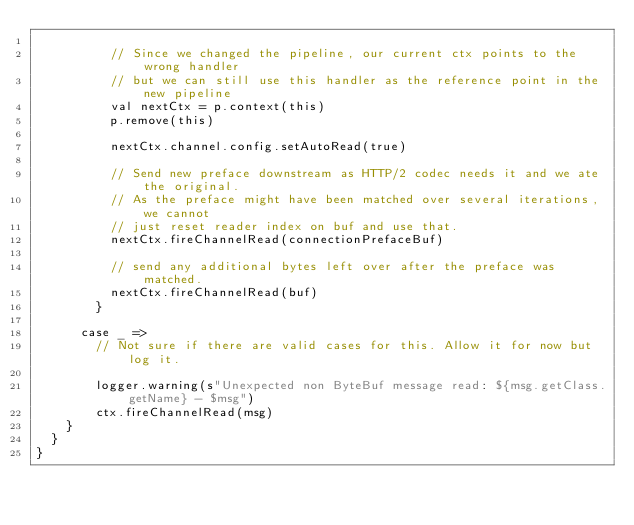Convert code to text. <code><loc_0><loc_0><loc_500><loc_500><_Scala_>
          // Since we changed the pipeline, our current ctx points to the wrong handler
          // but we can still use this handler as the reference point in the new pipeline
          val nextCtx = p.context(this)
          p.remove(this)

          nextCtx.channel.config.setAutoRead(true)

          // Send new preface downstream as HTTP/2 codec needs it and we ate the original.
          // As the preface might have been matched over several iterations, we cannot
          // just reset reader index on buf and use that.
          nextCtx.fireChannelRead(connectionPrefaceBuf)

          // send any additional bytes left over after the preface was matched.
          nextCtx.fireChannelRead(buf)
        }

      case _ =>
        // Not sure if there are valid cases for this. Allow it for now but log it.

        logger.warning(s"Unexpected non ByteBuf message read: ${msg.getClass.getName} - $msg")
        ctx.fireChannelRead(msg)
    }
  }
}
</code> 